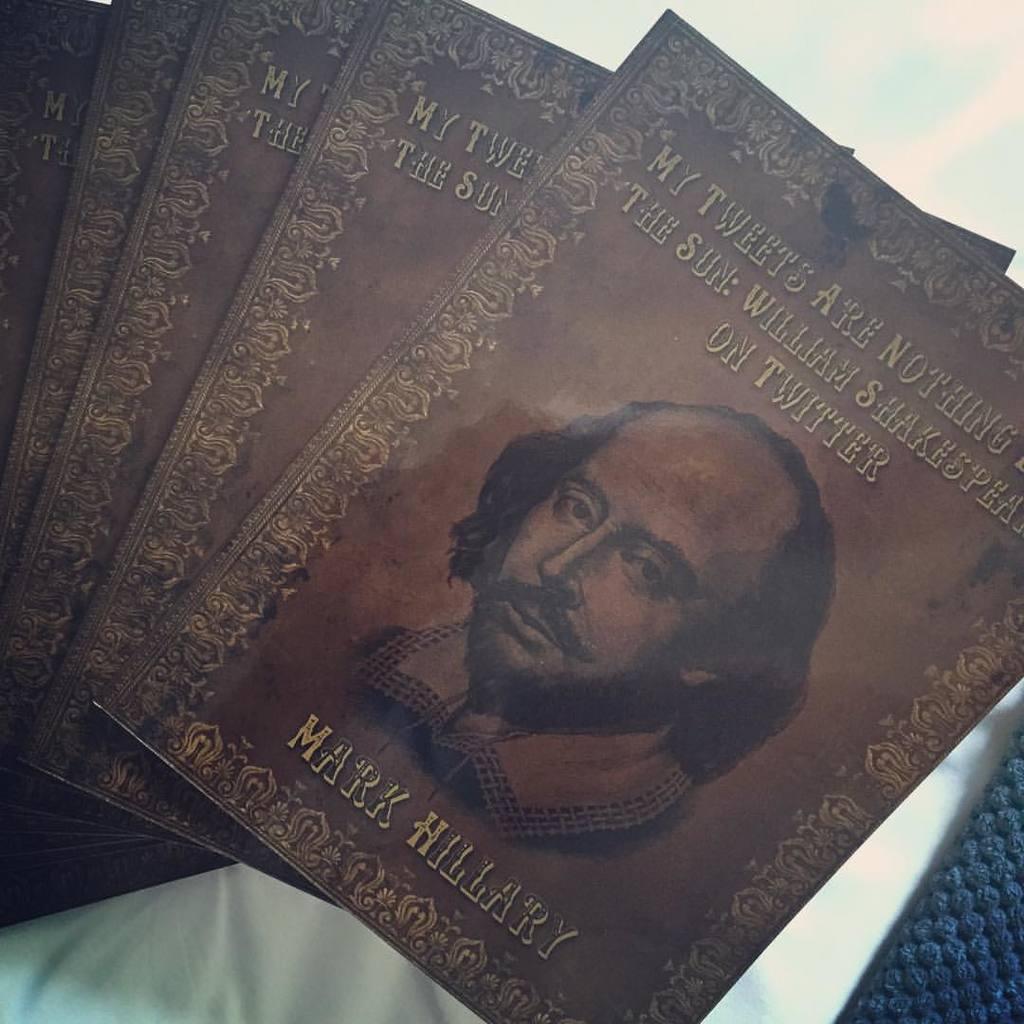Describe this image in one or two sentences. In this image there are a few books with an image of a man and there is a text on them. In the background there is a white surface. At the right bottom of the image there is a woolen cloth. 